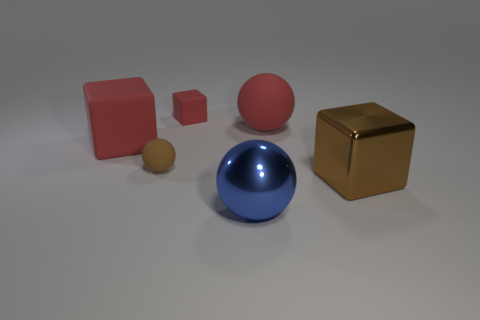Add 3 metal blocks. How many objects exist? 9 Subtract 1 red balls. How many objects are left? 5 Subtract all tiny purple things. Subtract all tiny brown balls. How many objects are left? 5 Add 5 small brown matte objects. How many small brown matte objects are left? 6 Add 1 balls. How many balls exist? 4 